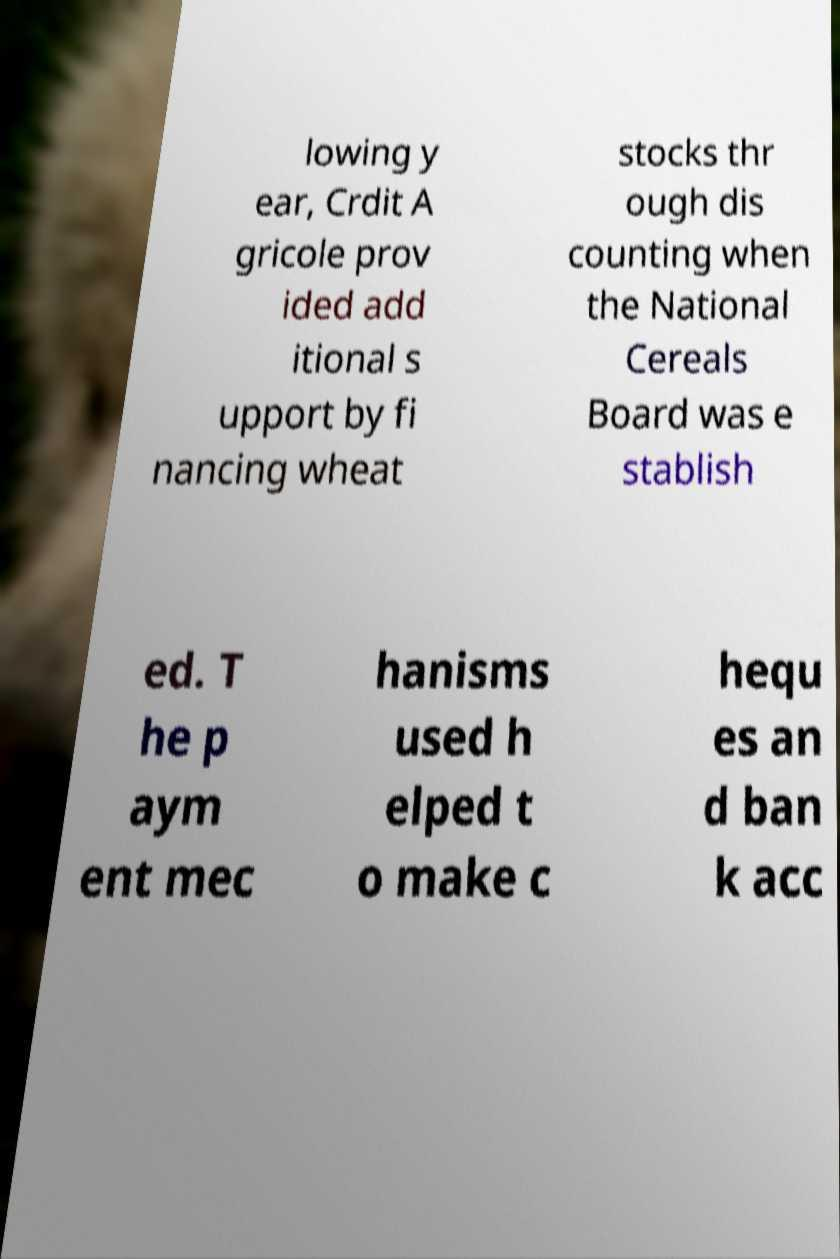Please identify and transcribe the text found in this image. lowing y ear, Crdit A gricole prov ided add itional s upport by fi nancing wheat stocks thr ough dis counting when the National Cereals Board was e stablish ed. T he p aym ent mec hanisms used h elped t o make c hequ es an d ban k acc 